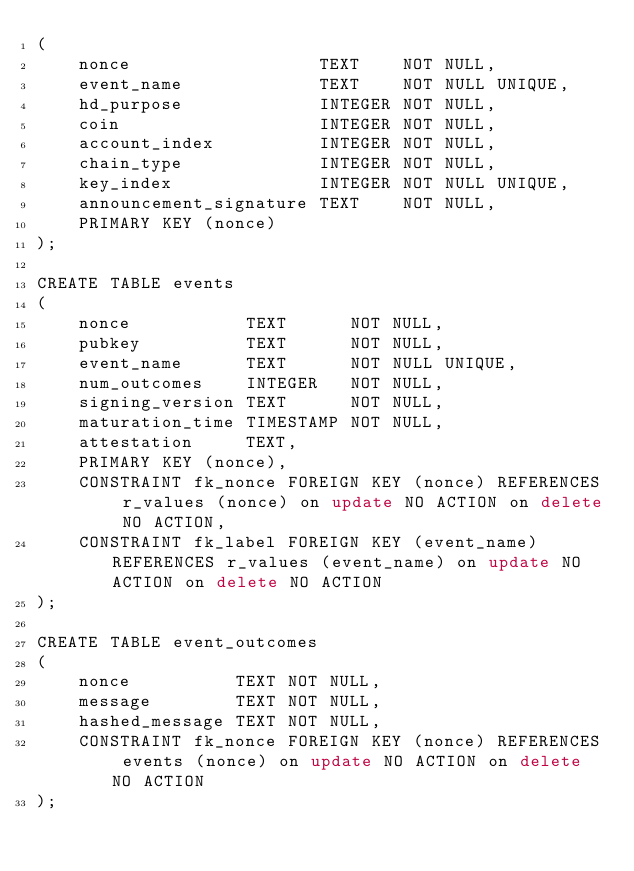Convert code to text. <code><loc_0><loc_0><loc_500><loc_500><_SQL_>(
    nonce                  TEXT    NOT NULL,
    event_name             TEXT    NOT NULL UNIQUE,
    hd_purpose             INTEGER NOT NULL,
    coin                   INTEGER NOT NULL,
    account_index          INTEGER NOT NULL,
    chain_type             INTEGER NOT NULL,
    key_index              INTEGER NOT NULL UNIQUE,
    announcement_signature TEXT    NOT NULL,
    PRIMARY KEY (nonce)
);

CREATE TABLE events
(
    nonce           TEXT      NOT NULL,
    pubkey          TEXT      NOT NULL,
    event_name      TEXT      NOT NULL UNIQUE,
    num_outcomes    INTEGER   NOT NULL,
    signing_version TEXT      NOT NULL,
    maturation_time TIMESTAMP NOT NULL,
    attestation     TEXT,
    PRIMARY KEY (nonce),
    CONSTRAINT fk_nonce FOREIGN KEY (nonce) REFERENCES r_values (nonce) on update NO ACTION on delete NO ACTION,
    CONSTRAINT fk_label FOREIGN KEY (event_name) REFERENCES r_values (event_name) on update NO ACTION on delete NO ACTION
);

CREATE TABLE event_outcomes
(
    nonce          TEXT NOT NULL,
    message        TEXT NOT NULL,
    hashed_message TEXT NOT NULL,
    CONSTRAINT fk_nonce FOREIGN KEY (nonce) REFERENCES events (nonce) on update NO ACTION on delete NO ACTION
);
</code> 